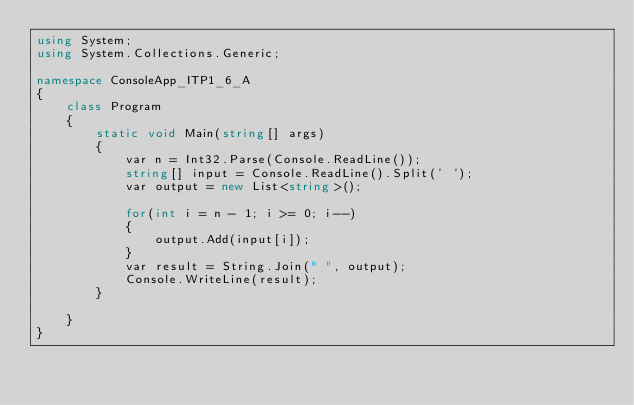Convert code to text. <code><loc_0><loc_0><loc_500><loc_500><_C#_>using System;
using System.Collections.Generic;

namespace ConsoleApp_ITP1_6_A
{
    class Program
    {
        static void Main(string[] args)
        {
            var n = Int32.Parse(Console.ReadLine());
            string[] input = Console.ReadLine().Split(' ');
            var output = new List<string>();

            for(int i = n - 1; i >= 0; i--)
            {
                output.Add(input[i]);
            }
            var result = String.Join(" ", output);
            Console.WriteLine(result);
        }

    }
}

</code> 